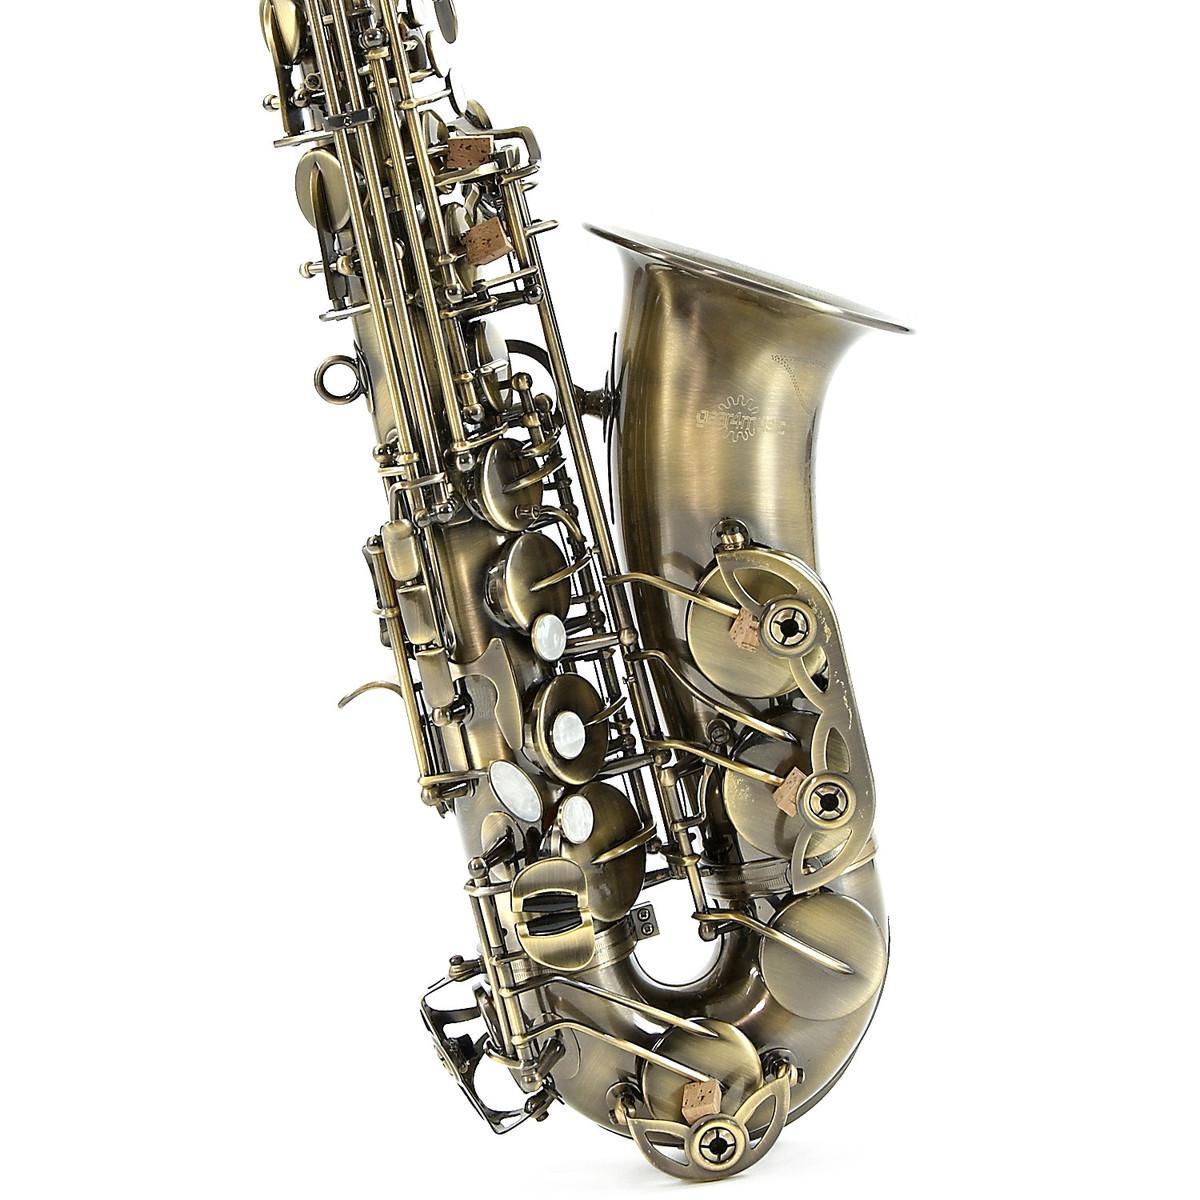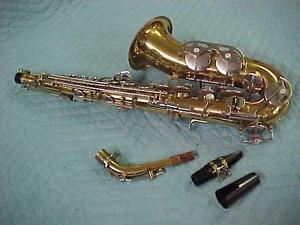The first image is the image on the left, the second image is the image on the right. Examine the images to the left and right. Is the description "The saxophones are all sitting upright and facing to the right." accurate? Answer yes or no. No. 